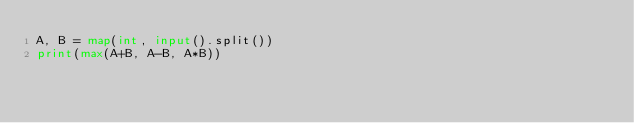Convert code to text. <code><loc_0><loc_0><loc_500><loc_500><_Python_>A, B = map(int, input().split())
print(max(A+B, A-B, A*B))</code> 